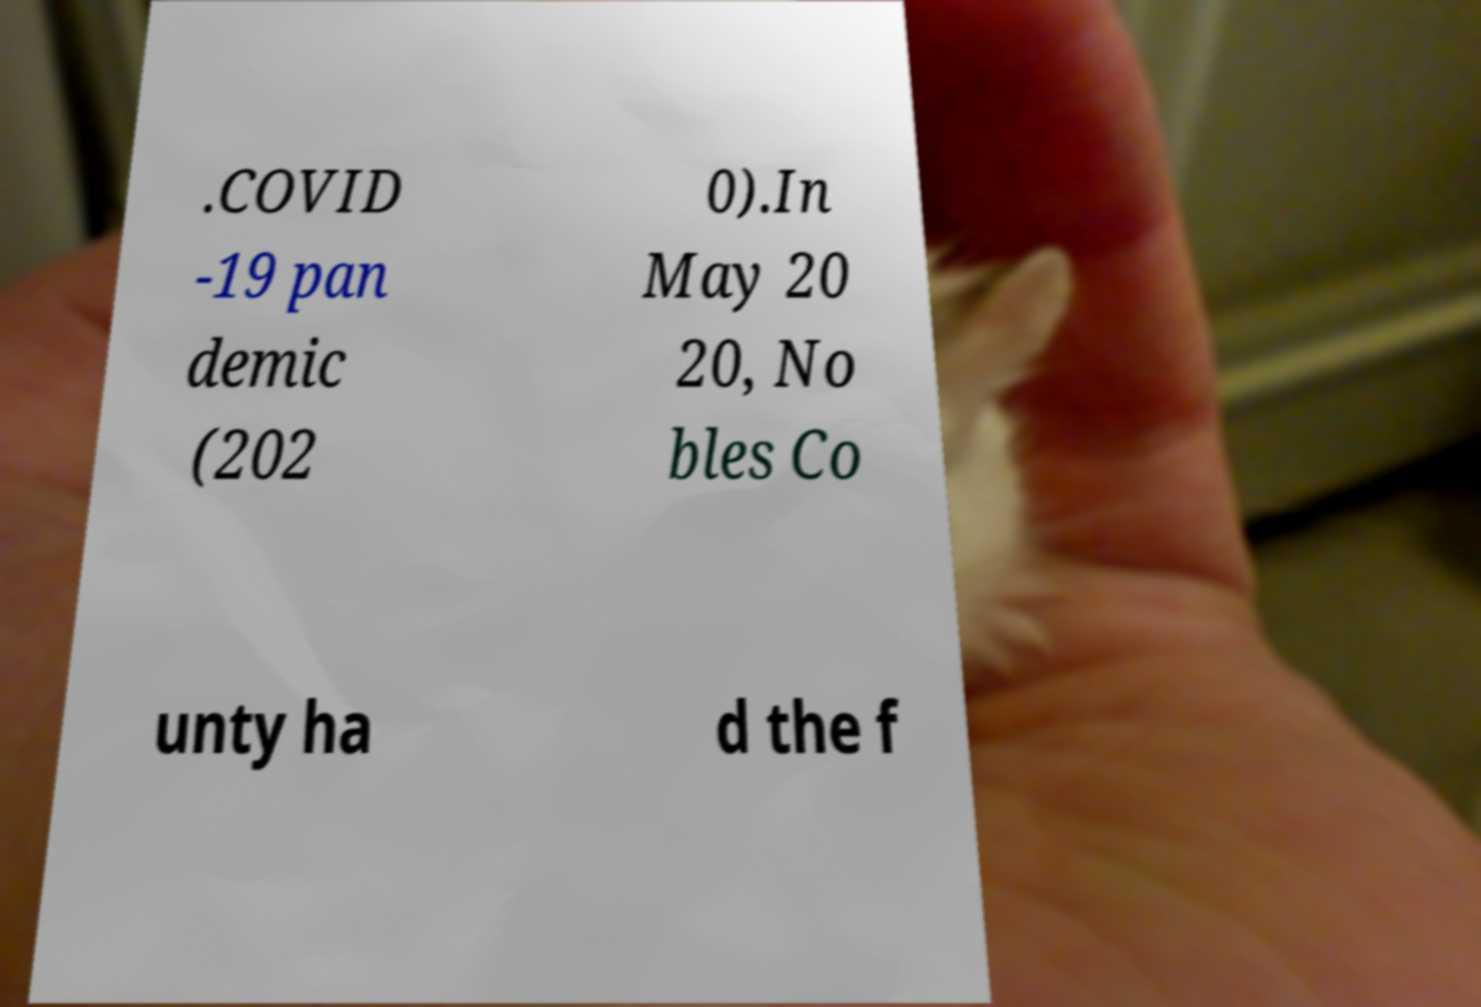Please identify and transcribe the text found in this image. .COVID -19 pan demic (202 0).In May 20 20, No bles Co unty ha d the f 